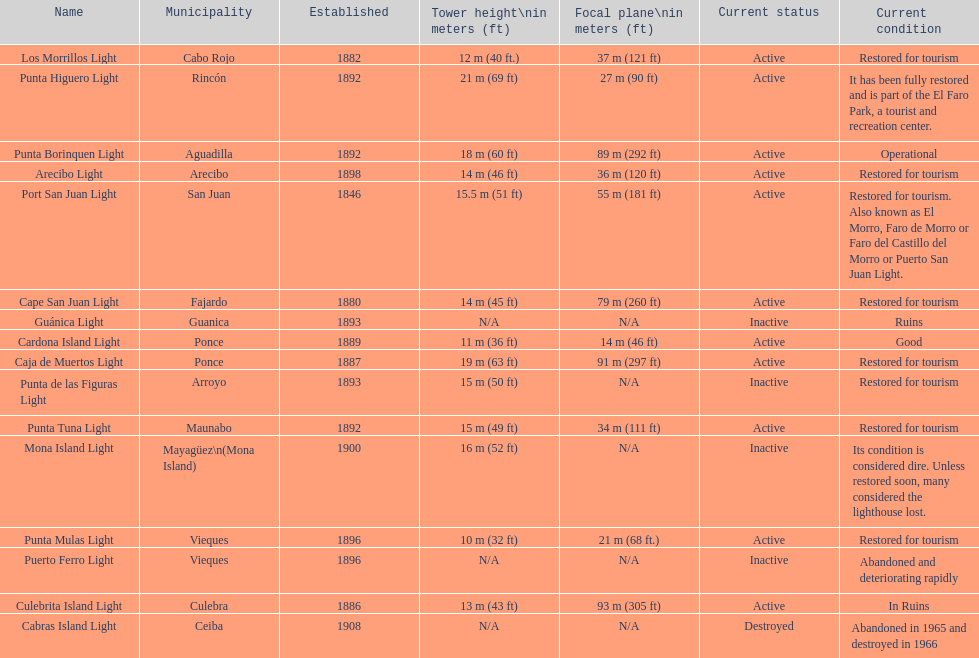The range in years between 1882 and 1889 7. Could you parse the entire table as a dict? {'header': ['Name', 'Municipality', 'Established', 'Tower height\\nin meters (ft)', 'Focal plane\\nin meters (ft)', 'Current status', 'Current condition'], 'rows': [['Los Morrillos Light', 'Cabo Rojo', '1882', '12\xa0m (40\xa0ft.)', '37\xa0m (121\xa0ft)', 'Active', 'Restored for tourism'], ['Punta Higuero Light', 'Rincón', '1892', '21\xa0m (69\xa0ft)', '27\xa0m (90\xa0ft)', 'Active', 'It has been fully restored and is part of the El Faro Park, a tourist and recreation center.'], ['Punta Borinquen Light', 'Aguadilla', '1892', '18\xa0m (60\xa0ft)', '89\xa0m (292\xa0ft)', 'Active', 'Operational'], ['Arecibo Light', 'Arecibo', '1898', '14\xa0m (46\xa0ft)', '36\xa0m (120\xa0ft)', 'Active', 'Restored for tourism'], ['Port San Juan Light', 'San Juan', '1846', '15.5\xa0m (51\xa0ft)', '55\xa0m (181\xa0ft)', 'Active', 'Restored for tourism. Also known as El Morro, Faro de Morro or Faro del Castillo del Morro or Puerto San Juan Light.'], ['Cape San Juan Light', 'Fajardo', '1880', '14\xa0m (45\xa0ft)', '79\xa0m (260\xa0ft)', 'Active', 'Restored for tourism'], ['Guánica Light', 'Guanica', '1893', 'N/A', 'N/A', 'Inactive', 'Ruins'], ['Cardona Island Light', 'Ponce', '1889', '11\xa0m (36\xa0ft)', '14\xa0m (46\xa0ft)', 'Active', 'Good'], ['Caja de Muertos Light', 'Ponce', '1887', '19\xa0m (63\xa0ft)', '91\xa0m (297\xa0ft)', 'Active', 'Restored for tourism'], ['Punta de las Figuras Light', 'Arroyo', '1893', '15\xa0m (50\xa0ft)', 'N/A', 'Inactive', 'Restored for tourism'], ['Punta Tuna Light', 'Maunabo', '1892', '15\xa0m (49\xa0ft)', '34\xa0m (111\xa0ft)', 'Active', 'Restored for tourism'], ['Mona Island Light', 'Mayagüez\\n(Mona Island)', '1900', '16\xa0m (52\xa0ft)', 'N/A', 'Inactive', 'Its condition is considered dire. Unless restored soon, many considered the lighthouse lost.'], ['Punta Mulas Light', 'Vieques', '1896', '10\xa0m (32\xa0ft)', '21\xa0m (68\xa0ft.)', 'Active', 'Restored for tourism'], ['Puerto Ferro Light', 'Vieques', '1896', 'N/A', 'N/A', 'Inactive', 'Abandoned and deteriorating rapidly'], ['Culebrita Island Light', 'Culebra', '1886', '13\xa0m (43\xa0ft)', '93\xa0m (305\xa0ft)', 'Active', 'In Ruins'], ['Cabras Island Light', 'Ceiba', '1908', 'N/A', 'N/A', 'Destroyed', 'Abandoned in 1965 and destroyed in 1966']]} 